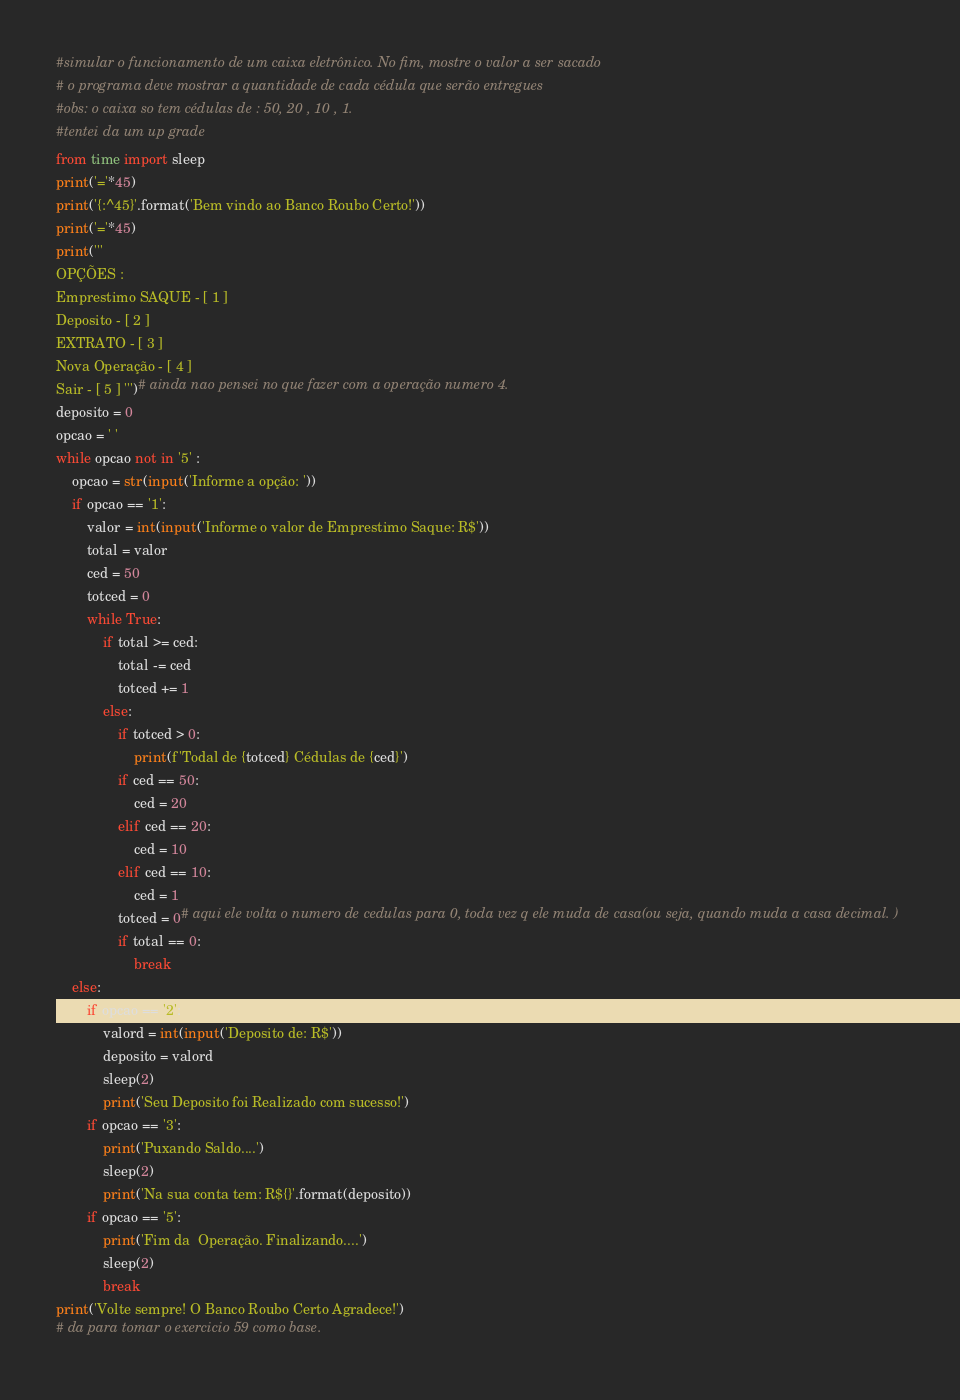Convert code to text. <code><loc_0><loc_0><loc_500><loc_500><_Python_>#simular o funcionamento de um caixa eletrônico. No fim, mostre o valor a ser sacado 
# o programa deve mostrar a quantidade de cada cédula que serão entregues
#obs: o caixa so tem cédulas de : 50, 20 , 10 , 1. 
#tentei da um up grade
from time import sleep
print('='*45)
print('{:^45}'.format('Bem vindo ao Banco Roubo Certo!'))
print('='*45)
print('''
OPÇÕES :
Emprestimo SAQUE - [ 1 ]
Deposito - [ 2 ] 
EXTRATO - [ 3 ]
Nova Operação - [ 4 ]
Sair - [ 5 ] ''')# ainda nao pensei no que fazer com a operação numero 4.  
deposito = 0
opcao = ' '
while opcao not in '5' :
    opcao = str(input('Informe a opção: '))
    if opcao == '1':
        valor = int(input('Informe o valor de Emprestimo Saque: R$'))
        total = valor
        ced = 50
        totced = 0
        while True:
            if total >= ced:
                total -= ced
                totced += 1
            else:
                if totced > 0:
                    print(f'Todal de {totced} Cédulas de {ced}')
                if ced == 50:
                    ced = 20
                elif ced == 20:
                    ced = 10
                elif ced == 10:
                    ced = 1
                totced = 0# aqui ele volta o numero de cedulas para 0, toda vez q ele muda de casa(ou seja, quando muda a casa decimal. )
                if total == 0:
                    break
    else:
        if opcao == '2':
            valord = int(input('Deposito de: R$'))
            deposito = valord
            sleep(2)
            print('Seu Deposito foi Realizado com sucesso!')
        if opcao == '3':
            print('Puxando Saldo....')
            sleep(2)
            print('Na sua conta tem: R${}'.format(deposito))
        if opcao == '5':
            print('Fim da  Operação. Finalizando....') 
            sleep(2)
            break
print('Volte sempre! O Banco Roubo Certo Agradece!')
# da para tomar o exercicio 59 como base. 
</code> 